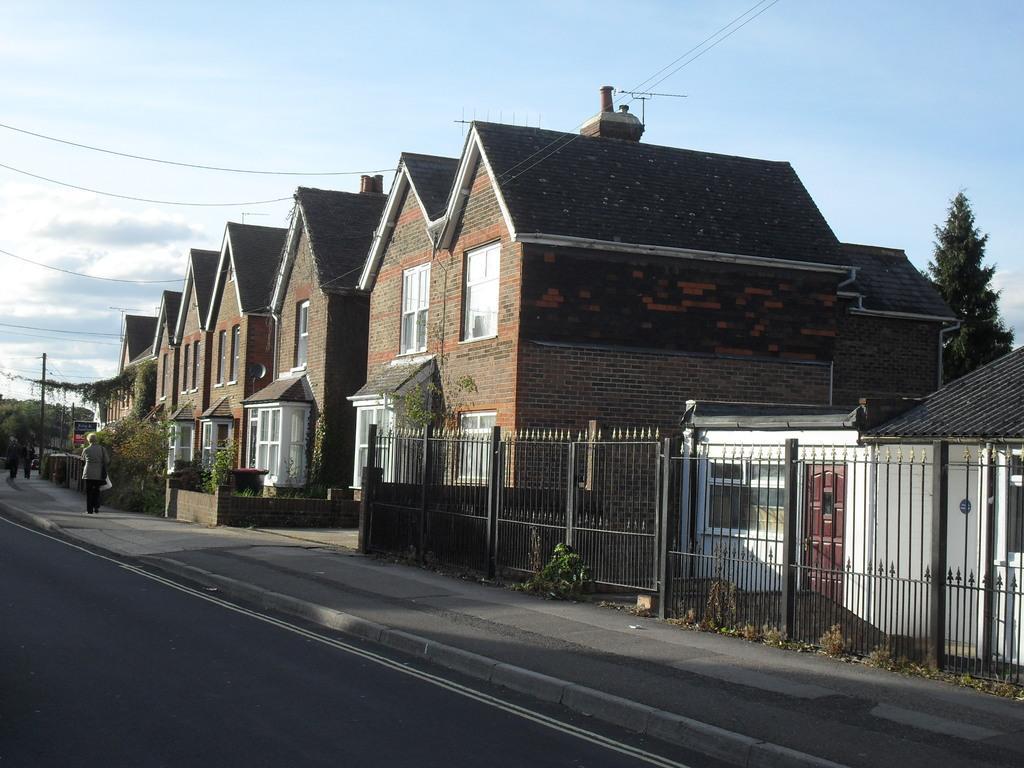Please provide a concise description of this image. Here in this picture we can see houses present over a place and we can also see its windows and we can see gates and fencing present in the front and we can also see plants and trees on the ground and we can see people standing and walking on the road and we can see clouds in the sky. 